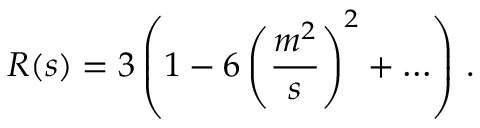<formula> <loc_0><loc_0><loc_500><loc_500>R ( s ) = 3 \left ( 1 - 6 \left ( { \frac { m ^ { 2 } } { s } } \right ) ^ { 2 } + \dots \right ) \, .</formula> 